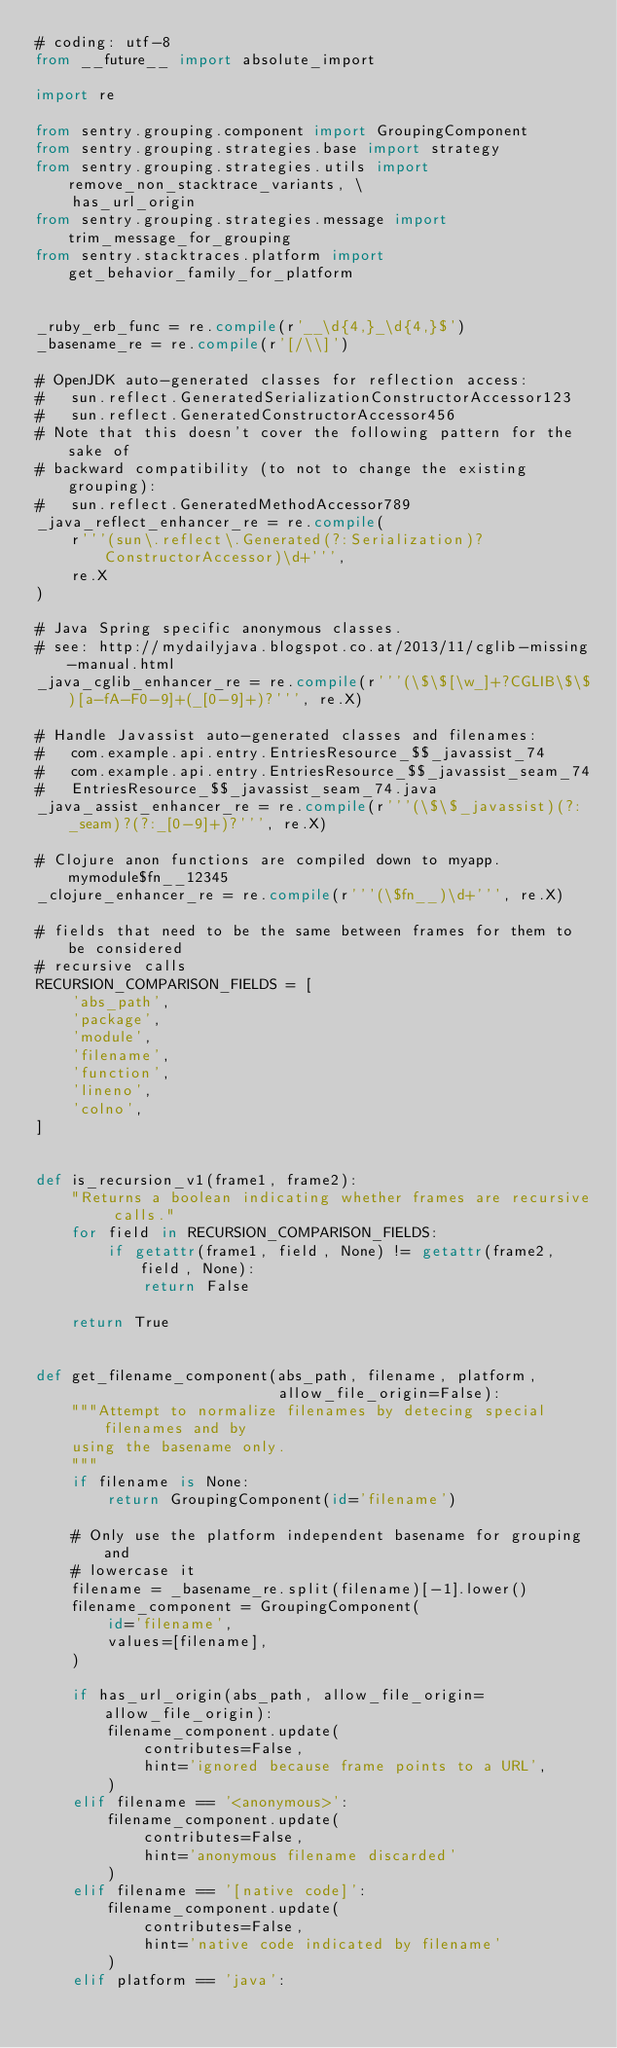<code> <loc_0><loc_0><loc_500><loc_500><_Python_># coding: utf-8
from __future__ import absolute_import

import re

from sentry.grouping.component import GroupingComponent
from sentry.grouping.strategies.base import strategy
from sentry.grouping.strategies.utils import remove_non_stacktrace_variants, \
    has_url_origin
from sentry.grouping.strategies.message import trim_message_for_grouping
from sentry.stacktraces.platform import get_behavior_family_for_platform


_ruby_erb_func = re.compile(r'__\d{4,}_\d{4,}$')
_basename_re = re.compile(r'[/\\]')

# OpenJDK auto-generated classes for reflection access:
#   sun.reflect.GeneratedSerializationConstructorAccessor123
#   sun.reflect.GeneratedConstructorAccessor456
# Note that this doesn't cover the following pattern for the sake of
# backward compatibility (to not to change the existing grouping):
#   sun.reflect.GeneratedMethodAccessor789
_java_reflect_enhancer_re = re.compile(
    r'''(sun\.reflect\.Generated(?:Serialization)?ConstructorAccessor)\d+''',
    re.X
)

# Java Spring specific anonymous classes.
# see: http://mydailyjava.blogspot.co.at/2013/11/cglib-missing-manual.html
_java_cglib_enhancer_re = re.compile(r'''(\$\$[\w_]+?CGLIB\$\$)[a-fA-F0-9]+(_[0-9]+)?''', re.X)

# Handle Javassist auto-generated classes and filenames:
#   com.example.api.entry.EntriesResource_$$_javassist_74
#   com.example.api.entry.EntriesResource_$$_javassist_seam_74
#   EntriesResource_$$_javassist_seam_74.java
_java_assist_enhancer_re = re.compile(r'''(\$\$_javassist)(?:_seam)?(?:_[0-9]+)?''', re.X)

# Clojure anon functions are compiled down to myapp.mymodule$fn__12345
_clojure_enhancer_re = re.compile(r'''(\$fn__)\d+''', re.X)

# fields that need to be the same between frames for them to be considered
# recursive calls
RECURSION_COMPARISON_FIELDS = [
    'abs_path',
    'package',
    'module',
    'filename',
    'function',
    'lineno',
    'colno',
]


def is_recursion_v1(frame1, frame2):
    "Returns a boolean indicating whether frames are recursive calls."
    for field in RECURSION_COMPARISON_FIELDS:
        if getattr(frame1, field, None) != getattr(frame2, field, None):
            return False

    return True


def get_filename_component(abs_path, filename, platform,
                           allow_file_origin=False):
    """Attempt to normalize filenames by detecing special filenames and by
    using the basename only.
    """
    if filename is None:
        return GroupingComponent(id='filename')

    # Only use the platform independent basename for grouping and
    # lowercase it
    filename = _basename_re.split(filename)[-1].lower()
    filename_component = GroupingComponent(
        id='filename',
        values=[filename],
    )

    if has_url_origin(abs_path, allow_file_origin=allow_file_origin):
        filename_component.update(
            contributes=False,
            hint='ignored because frame points to a URL',
        )
    elif filename == '<anonymous>':
        filename_component.update(
            contributes=False,
            hint='anonymous filename discarded'
        )
    elif filename == '[native code]':
        filename_component.update(
            contributes=False,
            hint='native code indicated by filename'
        )
    elif platform == 'java':</code> 